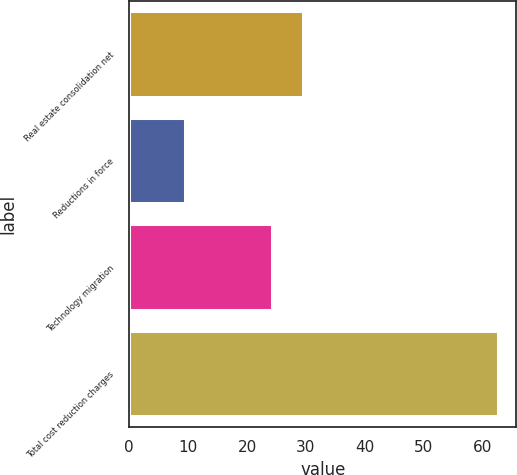Convert chart to OTSL. <chart><loc_0><loc_0><loc_500><loc_500><bar_chart><fcel>Real estate consolidation net<fcel>Reductions in force<fcel>Technology migration<fcel>Total cost reduction charges<nl><fcel>29.52<fcel>9.4<fcel>24.2<fcel>62.6<nl></chart> 